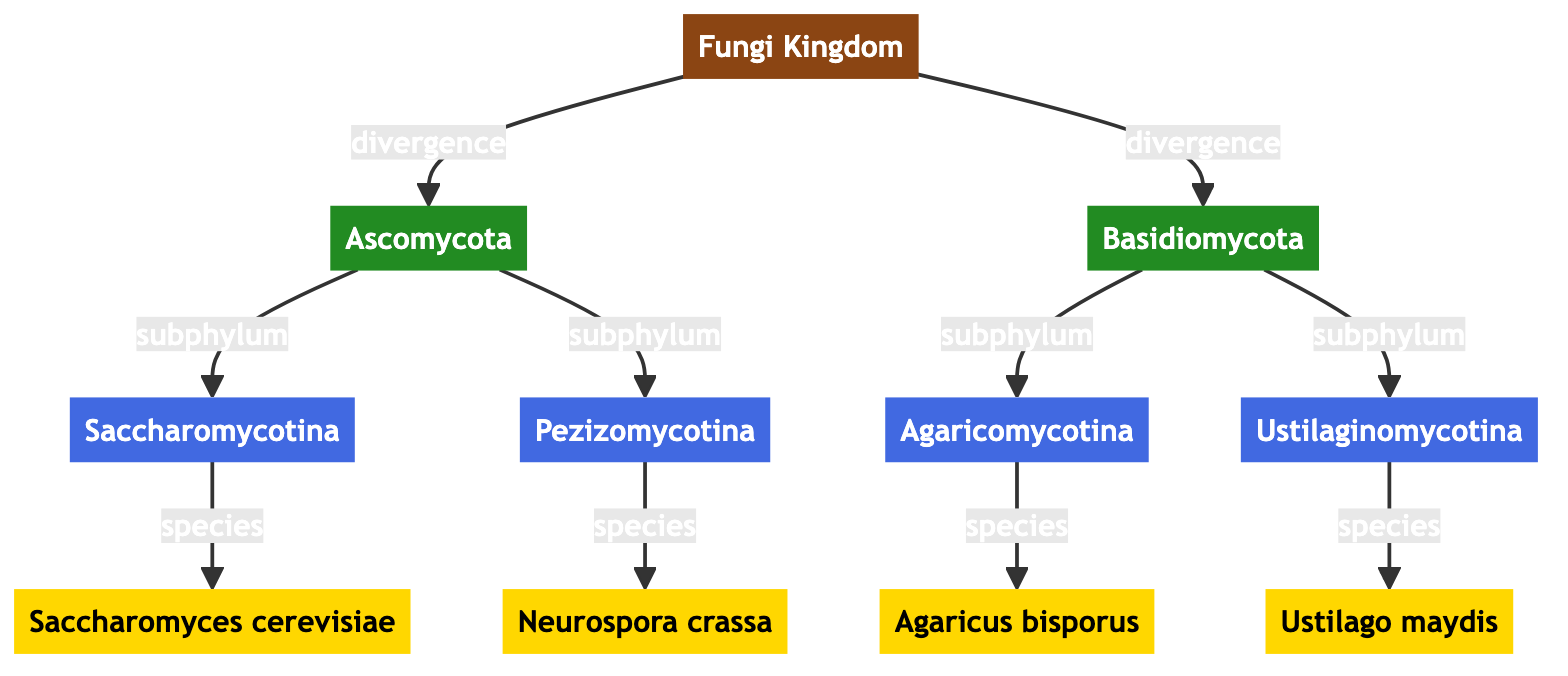What is the root node of the phylogenetic tree? The root node of the tree is labeled "Fungi Kingdom," which represents the starting point of the phylogenetic relationships depicted in the diagram.
Answer: Fungi Kingdom How many subphyla are present in the Ascomycota phylum? From the diagram, it is clear that the Ascomycota phylum branches into two subphyla: Saccharomycotina and Pezizomycotina. Thus, there are two subphyla present.
Answer: 2 Which species is connected to the Ustilaginomycotina subphylum? The Ustilaginomycotina subphylum has a direct connection to the species labeled "Ustilago maydis," demonstrating its position within this group.
Answer: Ustilago maydis What are the two phyla represented in the diagram? The two phyla represented in the diagram are Ascomycota and Basidiomycota, which branch from the root node of the Fungi Kingdom.
Answer: Ascomycota and Basidiomycota Which species among the listed ones belongs to the Basidiomycota phylum? The diagram indicates that "Agaricus bisporus" is linked to the Basidiomycota phylum, establishing it as a representative species of this group.
Answer: Agaricus bisporus How many total species are depicted in the tree? By counting the species nodes at the terminal points of the tree, there are four species listed: Saccharomyces cerevisiae, Neurospora crassa, Agaricus bisporus, and Ustilago maydis, resulting in a total of four species depicted.
Answer: 4 Which subphylum does Neurospora crassa belong to? Neurospora crassa is connected under the Pezizomycotina subphylum, indicating its specific classification within this group of fungi.
Answer: Pezizomycotina Which type of relationship is depicted between the Fungi Kingdom and the Ascomycota phylum? The relationship shown between the Fungi Kingdom and the Ascomycota phylum is labeled as "divergence," signaling an evolutionary split from the root.
Answer: divergence 